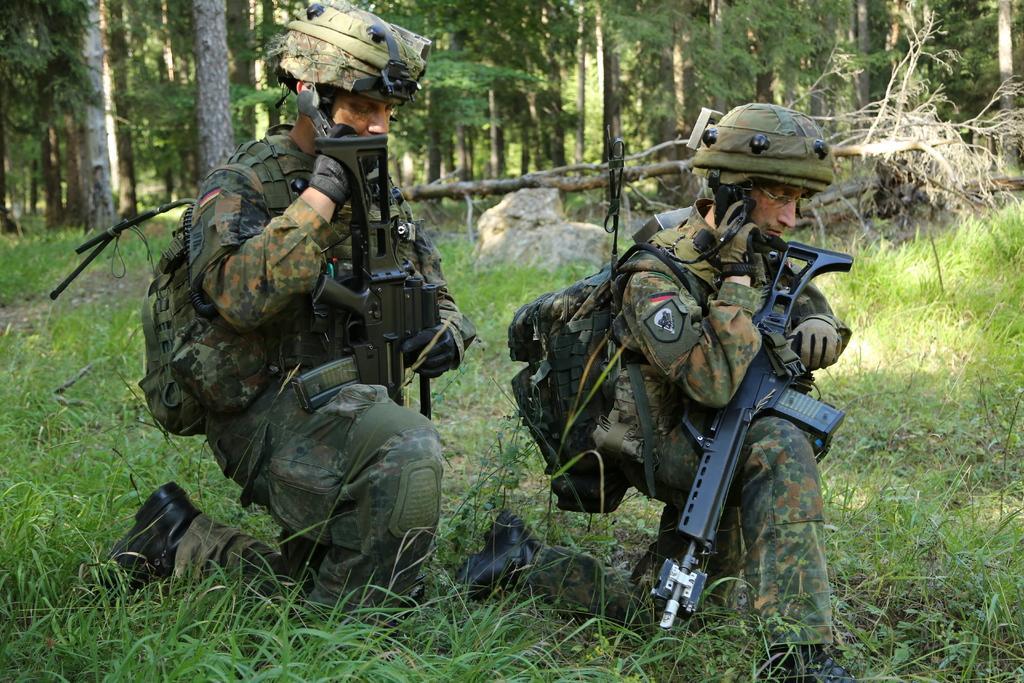How would you summarize this image in a sentence or two? In the center of the image we can see two people sitting and holding rifles in their hands. They are wearing uniforms. At the bottom there is grass. In the background there are trees and rocks. 